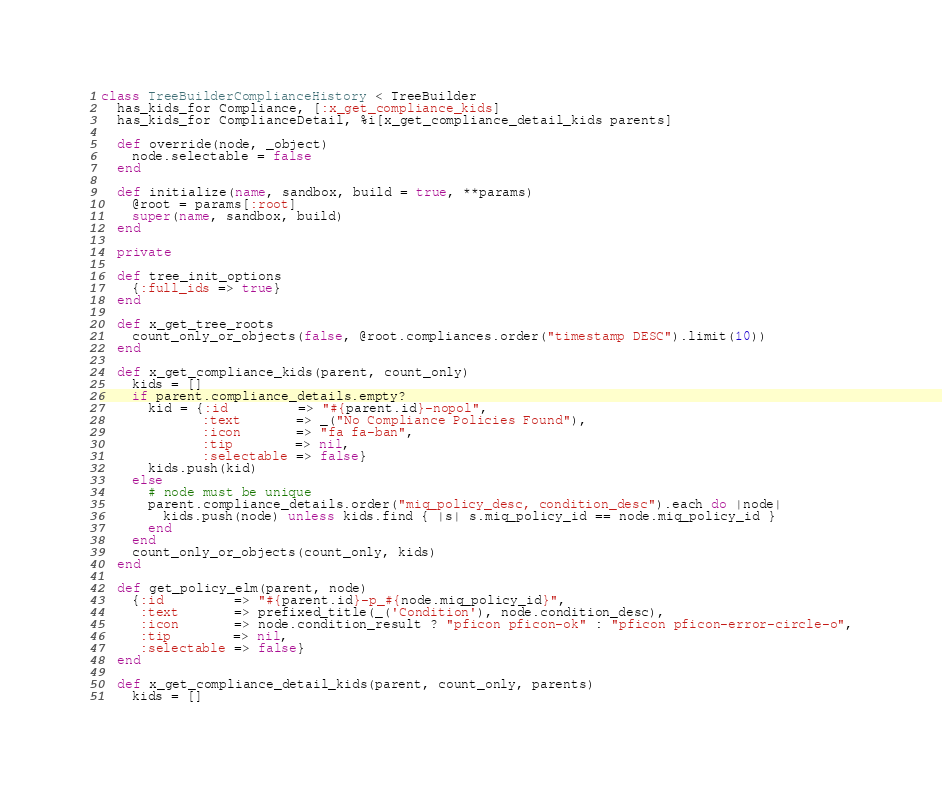Convert code to text. <code><loc_0><loc_0><loc_500><loc_500><_Ruby_>class TreeBuilderComplianceHistory < TreeBuilder
  has_kids_for Compliance, [:x_get_compliance_kids]
  has_kids_for ComplianceDetail, %i[x_get_compliance_detail_kids parents]

  def override(node, _object)
    node.selectable = false
  end

  def initialize(name, sandbox, build = true, **params)
    @root = params[:root]
    super(name, sandbox, build)
  end

  private

  def tree_init_options
    {:full_ids => true}
  end

  def x_get_tree_roots
    count_only_or_objects(false, @root.compliances.order("timestamp DESC").limit(10))
  end

  def x_get_compliance_kids(parent, count_only)
    kids = []
    if parent.compliance_details.empty?
      kid = {:id         => "#{parent.id}-nopol",
             :text       => _("No Compliance Policies Found"),
             :icon       => "fa fa-ban",
             :tip        => nil,
             :selectable => false}
      kids.push(kid)
    else
      # node must be unique
      parent.compliance_details.order("miq_policy_desc, condition_desc").each do |node|
        kids.push(node) unless kids.find { |s| s.miq_policy_id == node.miq_policy_id }
      end
    end
    count_only_or_objects(count_only, kids)
  end

  def get_policy_elm(parent, node)
    {:id         => "#{parent.id}-p_#{node.miq_policy_id}",
     :text       => prefixed_title(_('Condition'), node.condition_desc),
     :icon       => node.condition_result ? "pficon pficon-ok" : "pficon pficon-error-circle-o",
     :tip        => nil,
     :selectable => false}
  end

  def x_get_compliance_detail_kids(parent, count_only, parents)
    kids = []</code> 